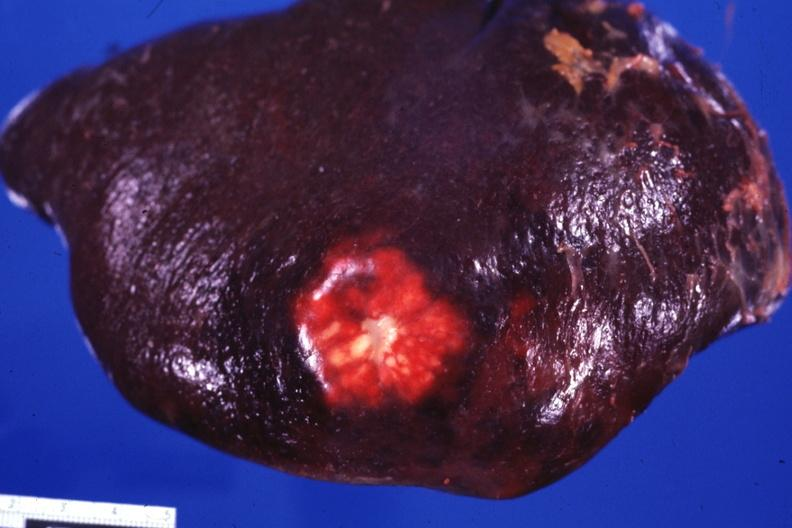s this section present?
Answer the question using a single word or phrase. No 